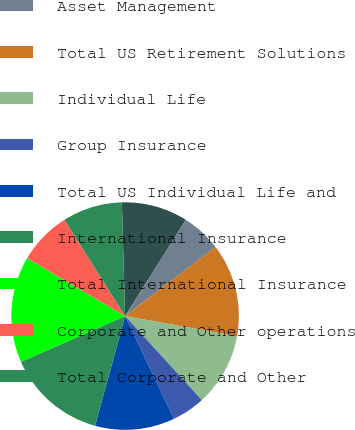Convert chart. <chart><loc_0><loc_0><loc_500><loc_500><pie_chart><fcel>Retirement<fcel>Asset Management<fcel>Total US Retirement Solutions<fcel>Individual Life<fcel>Group Insurance<fcel>Total US Individual Life and<fcel>International Insurance<fcel>Total International Insurance<fcel>Corporate and Other operations<fcel>Total Corporate and Other<nl><fcel>9.43%<fcel>5.66%<fcel>13.21%<fcel>10.38%<fcel>4.72%<fcel>11.32%<fcel>14.15%<fcel>15.09%<fcel>7.55%<fcel>8.49%<nl></chart> 